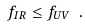<formula> <loc_0><loc_0><loc_500><loc_500>f _ { I R } \leq f _ { U V } \ .</formula> 